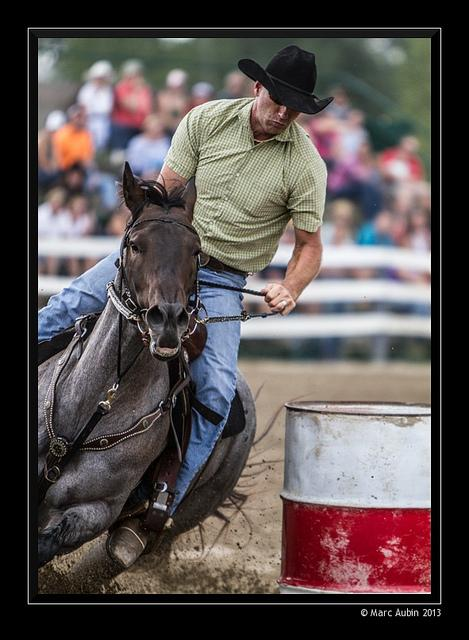What type activity does the man here take part in?

Choices:
A) barrel racing
B) bull riding
C) car race
D) roping barrel racing 